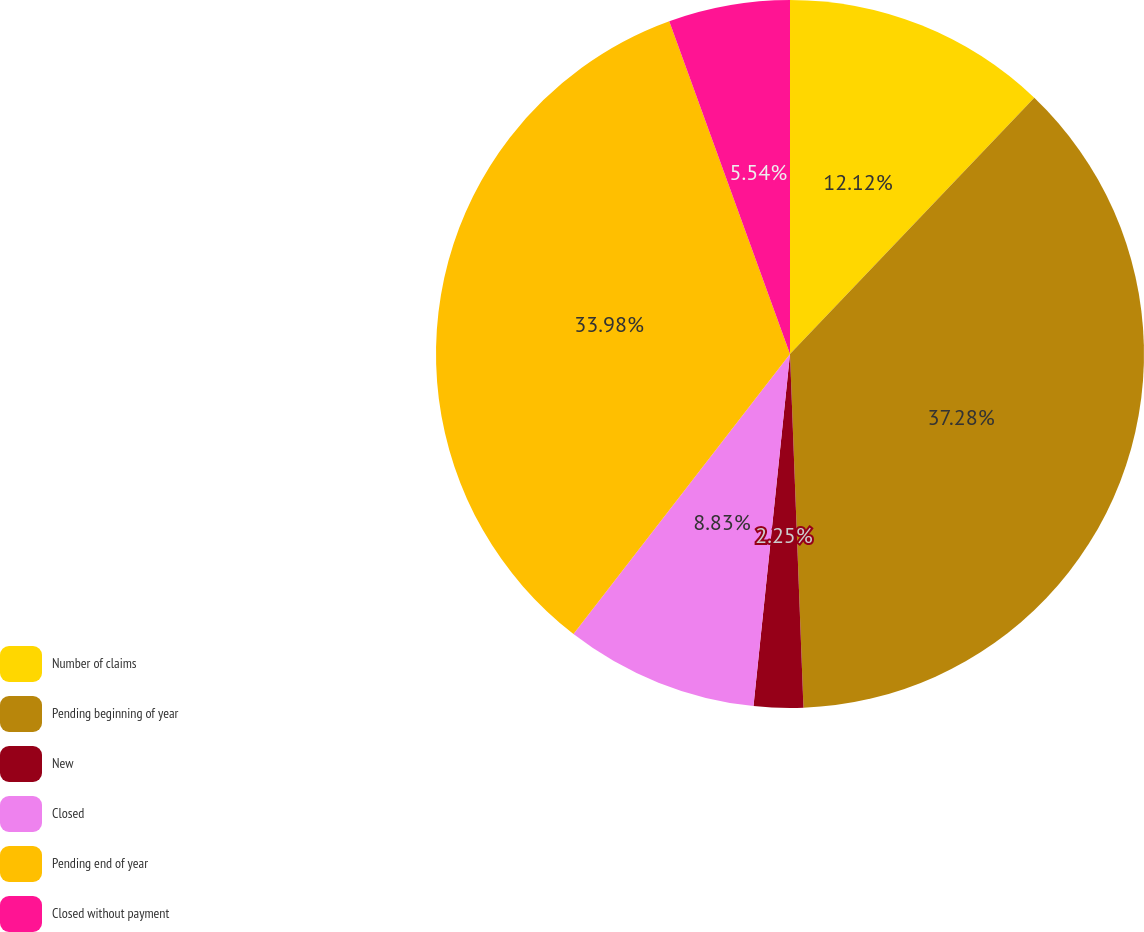Convert chart to OTSL. <chart><loc_0><loc_0><loc_500><loc_500><pie_chart><fcel>Number of claims<fcel>Pending beginning of year<fcel>New<fcel>Closed<fcel>Pending end of year<fcel>Closed without payment<nl><fcel>12.12%<fcel>37.27%<fcel>2.25%<fcel>8.83%<fcel>33.98%<fcel>5.54%<nl></chart> 